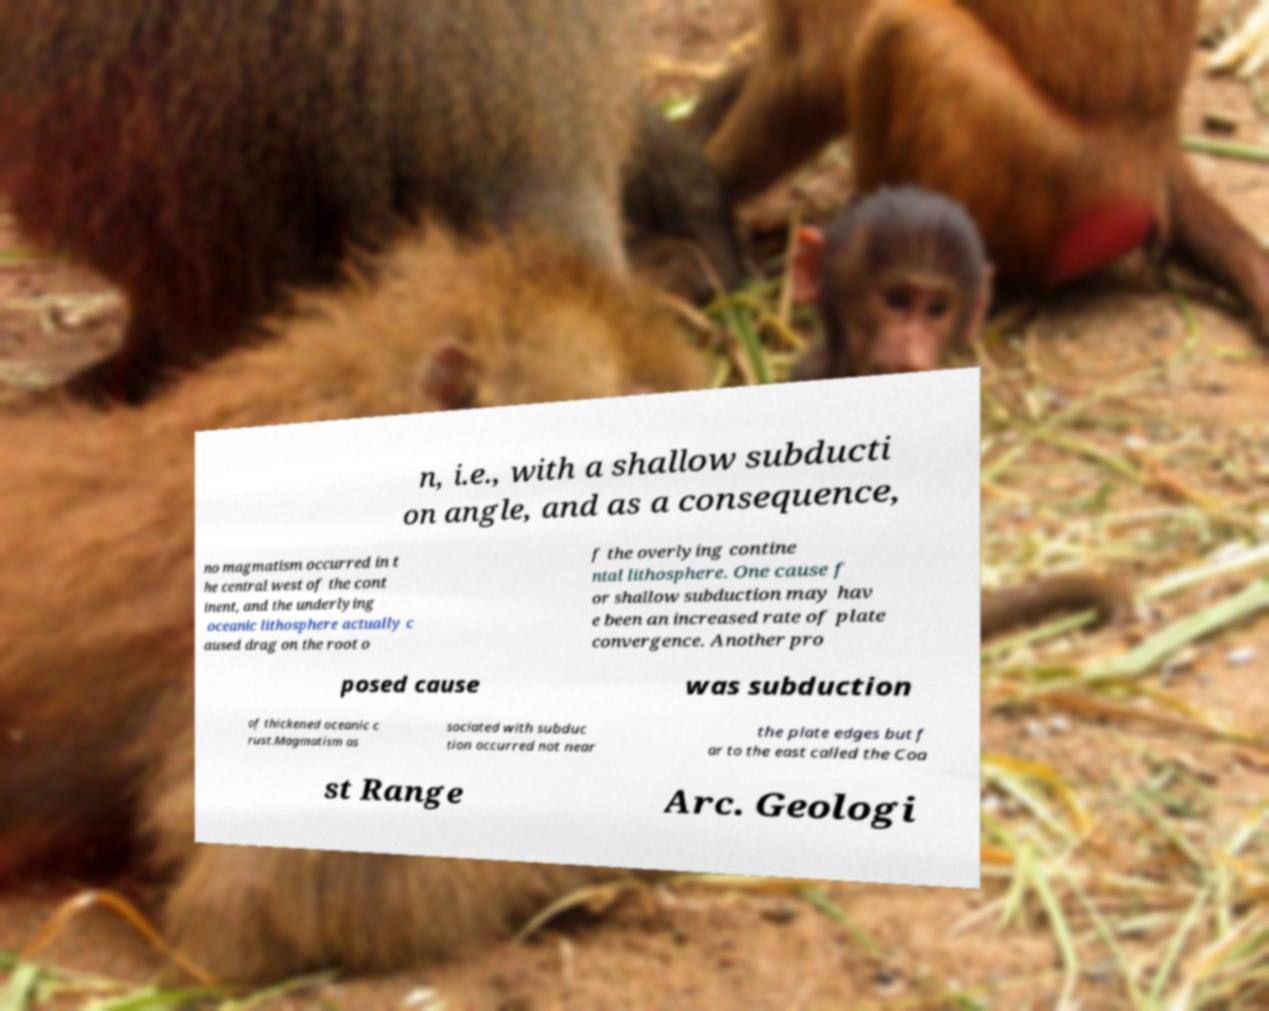Please read and relay the text visible in this image. What does it say? n, i.e., with a shallow subducti on angle, and as a consequence, no magmatism occurred in t he central west of the cont inent, and the underlying oceanic lithosphere actually c aused drag on the root o f the overlying contine ntal lithosphere. One cause f or shallow subduction may hav e been an increased rate of plate convergence. Another pro posed cause was subduction of thickened oceanic c rust.Magmatism as sociated with subduc tion occurred not near the plate edges but f ar to the east called the Coa st Range Arc. Geologi 